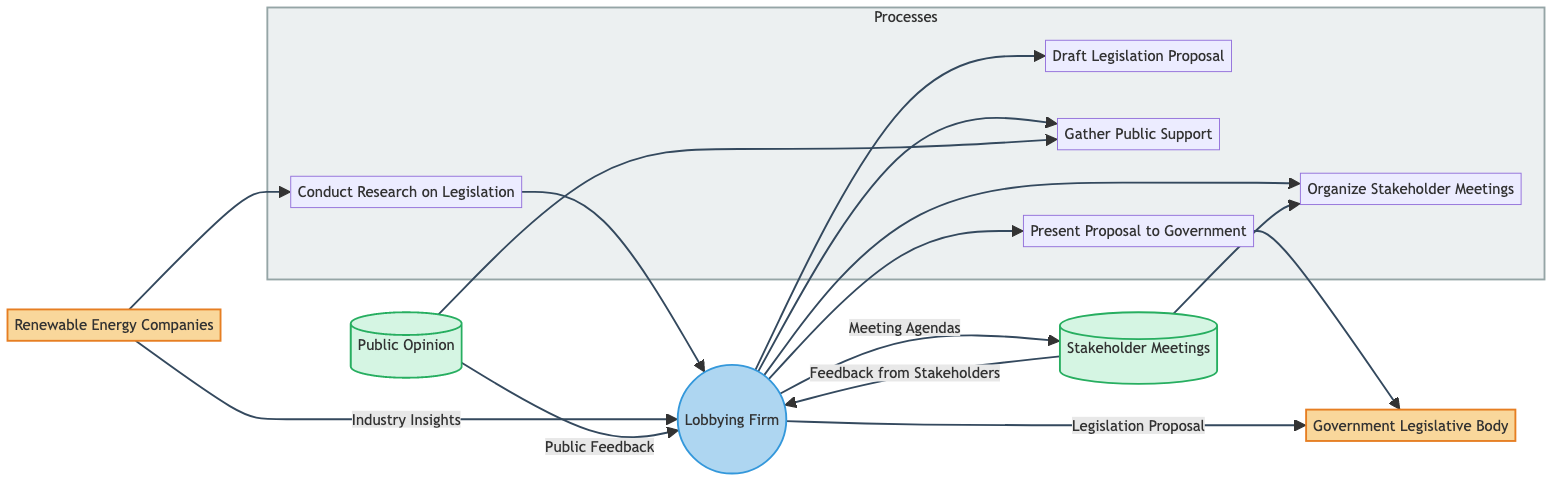What are the two external entities in this diagram? The diagram identifies "Renewable Energy Companies" and "Government Legislative Body" as the two external entities. External entities are usually depicted in a unique format.
Answer: Renewable Energy Companies, Government Legislative Body How many processes are represented in the diagram? The diagram contains a subgraph labeled "Processes" that includes five distinct processes: Conduct Research on Legislation, Draft Legislation Proposal, Gather Public Support, Organize Stakeholder Meetings, and Present Proposal to Government. Therefore, there are five processes in total.
Answer: 5 What type of data does "Public Opinion" data store contain? The "Public Opinion" data store includes two types of data: Surveys and Polls. Data stores typically record various types of information used by processes throughout the workflow.
Answer: Surveys, Polls Which process does "Feedback from Stakeholders" flow into? "Feedback from Stakeholders" flows from "Stakeholder Meetings" back into the "Lobbying Firm" process. This indicates that the Lobbying Firm uses this feedback to inform its actions or strategies.
Answer: Lobbying Firm What is the output of the "Draft Legislation Proposal" process? The output of the "Draft Legislation Proposal" process is directed towards the "Lobbying Firm." This indicates that the process is intended for internal use by the Lobbying Firm after the legislation proposal is drafted.
Answer: Lobbying Firm Which process incorporates "Public Feedback" into its workflow? The "Gather Public Support" process incorporates "Public Feedback" into its workflow, utilizing public opinion data to strengthen support for the proposed legislation. This is evident from the data flow connecting these two entities.
Answer: Gather Public Support How many unique data flows are shown in the diagram? The diagram presents five unique data flows connecting various nodes, each with a specified source, destination, and type of data being communicated. This count of connections answers the question regarding the complexity of interactions in the workflow.
Answer: 5 What data flow connects "Lobbying Firm" and "Government Legislative Body"? The data flow labeled "Legislation Proposal" connects "Lobbying Firm" and "Government Legislative Body," indicating that the lobbying team presents their proposal to the government as part of the legislative process.
Answer: Legislation Proposal 